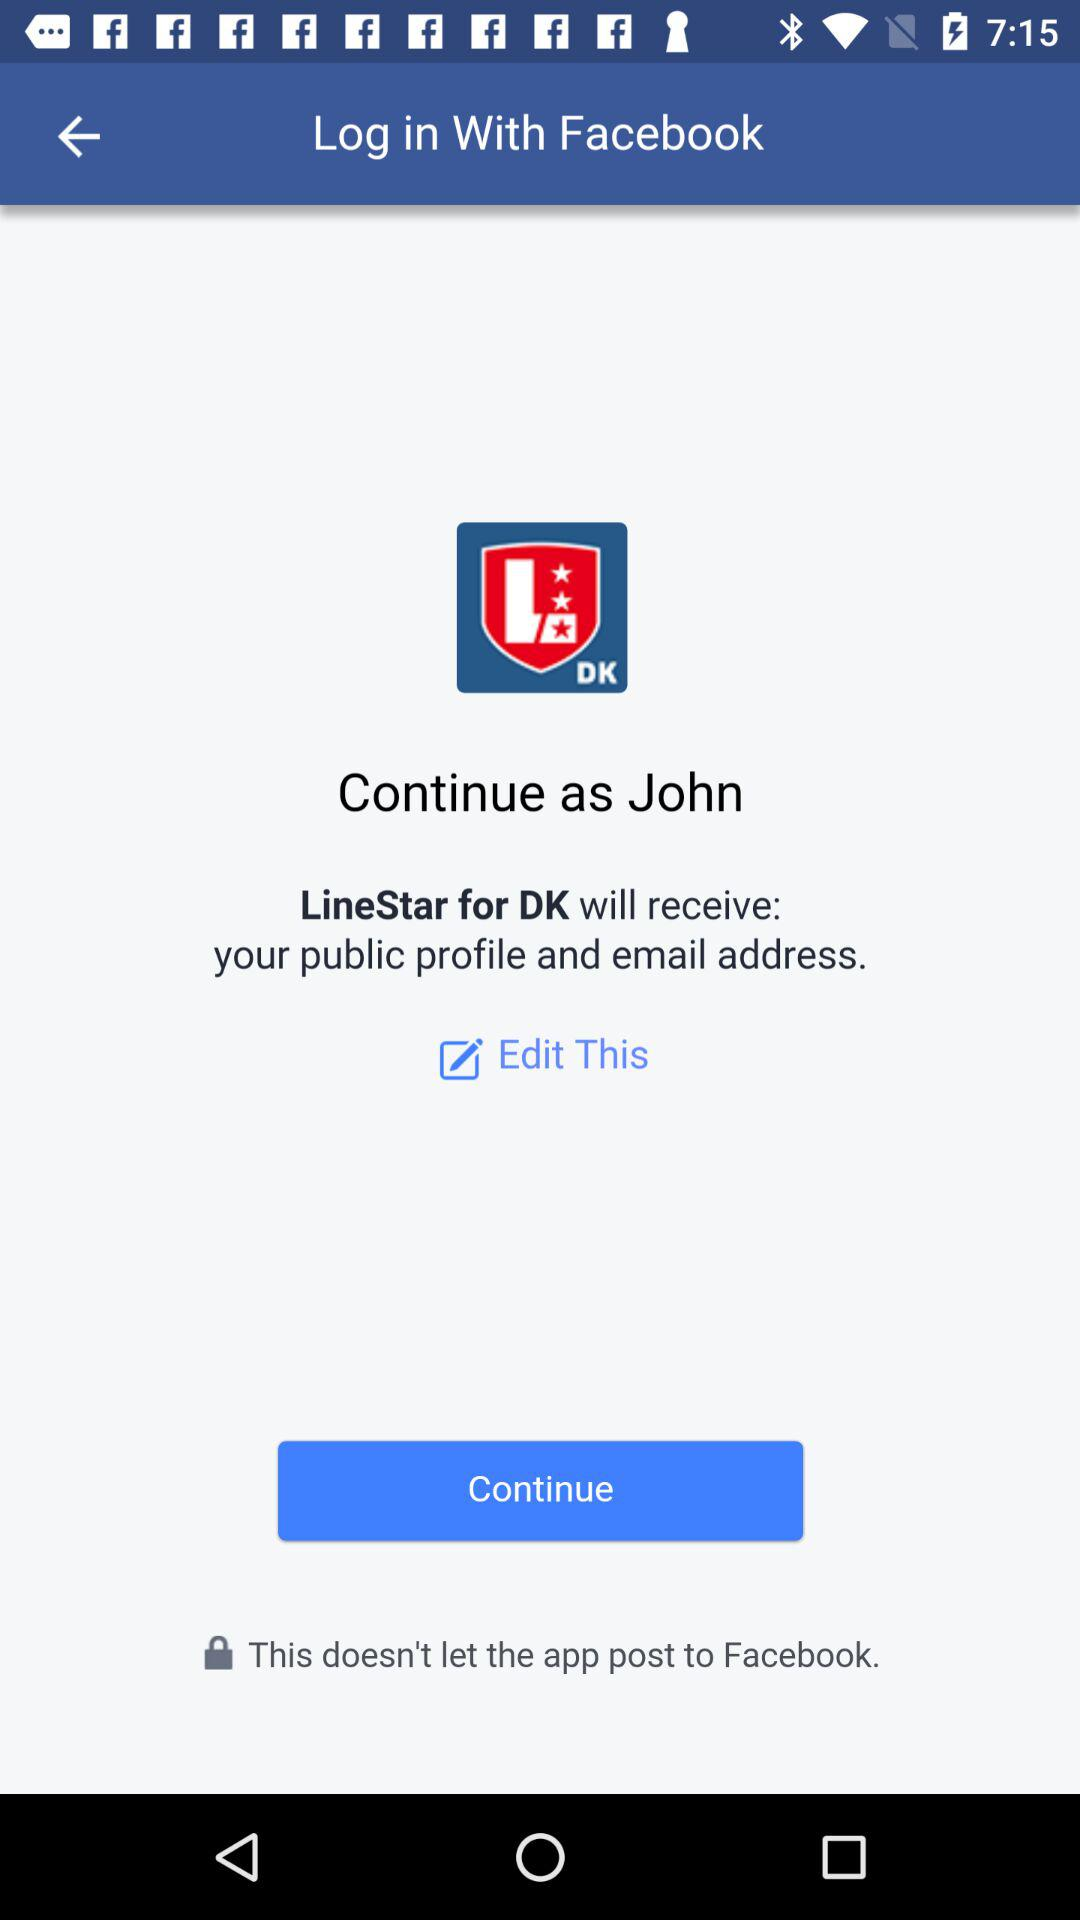What application is asking for permission? The application asking for permission is "LineStar for DK". 